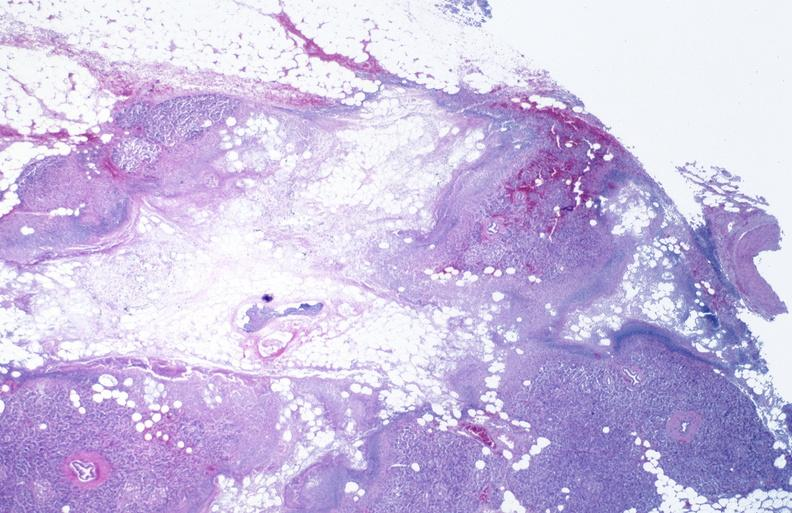does venous thrombosis show pancreatic fat necrosis?
Answer the question using a single word or phrase. No 